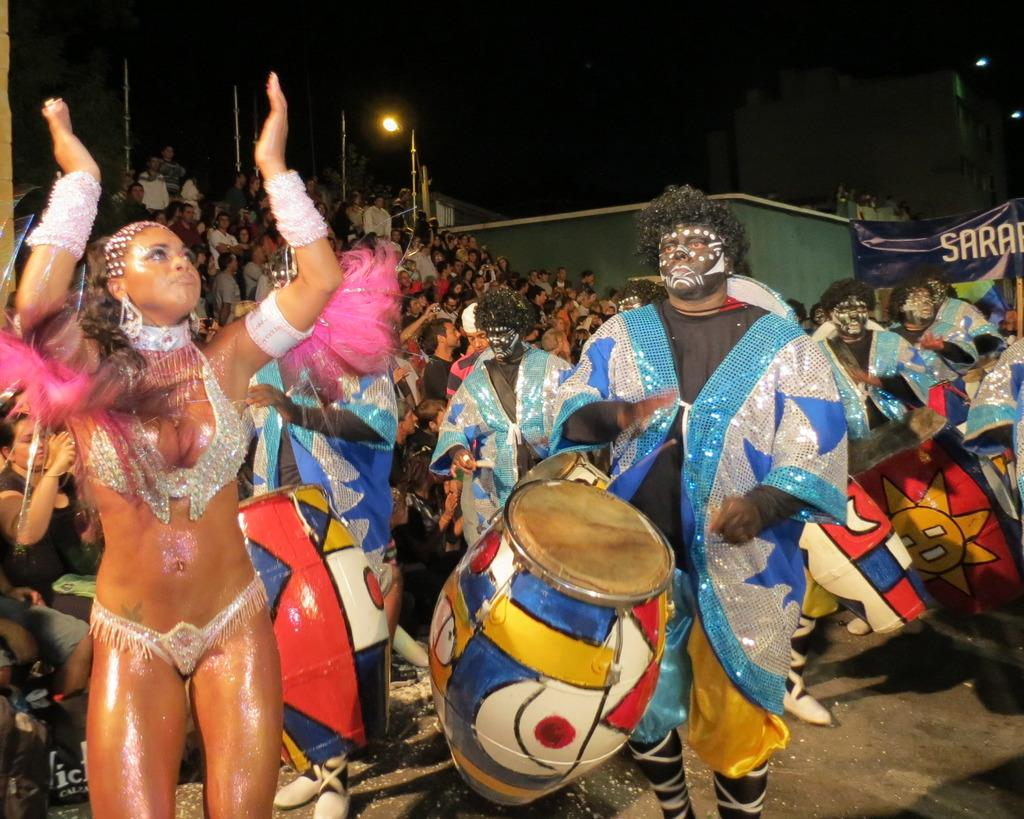What is happening in the image involving a group of people? Some people in the group are playing musical instruments. What else can be seen in the background of the image? There is a light, a banner, and the sky visible in the background of the image. What type of plough is being used by the people in the image? There is no plough present in the image; it features a group of people playing musical instruments. How many attempts can be seen being made by the people in the image? There is no indication of any attempts being made in the image, as it shows people playing musical instruments. 